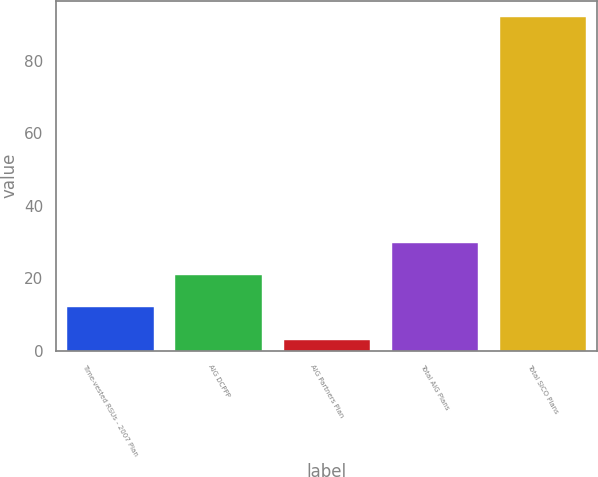Convert chart. <chart><loc_0><loc_0><loc_500><loc_500><bar_chart><fcel>Time-vested RSUs - 2007 Plan<fcel>AIG DCPPP<fcel>AIG Partners Plan<fcel>Total AIG Plans<fcel>Total SICO Plans<nl><fcel>11.9<fcel>20.8<fcel>3<fcel>29.7<fcel>92<nl></chart> 